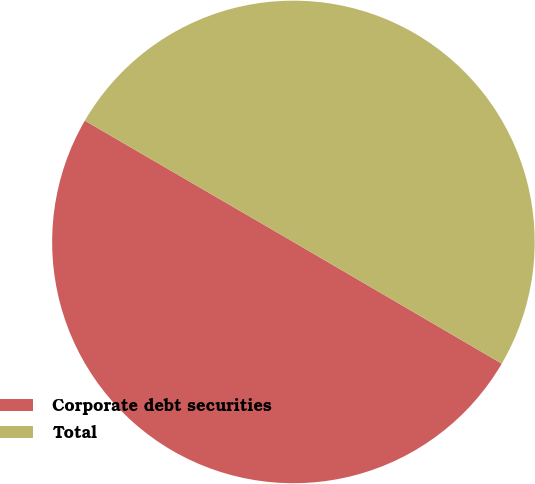<chart> <loc_0><loc_0><loc_500><loc_500><pie_chart><fcel>Corporate debt securities<fcel>Total<nl><fcel>49.97%<fcel>50.03%<nl></chart> 